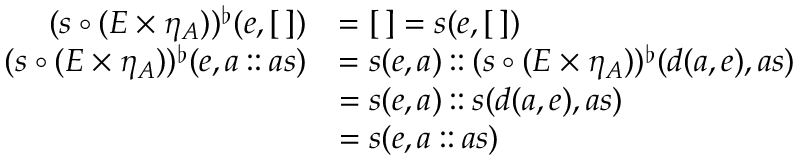Convert formula to latex. <formula><loc_0><loc_0><loc_500><loc_500>\begin{array} { r l } { ( s \circ ( E \times \eta _ { A } ) ) ^ { \flat } ( e , [ \, ] ) } & { = [ \, ] = s ( e , [ \, ] ) } \\ { ( s \circ ( E \times \eta _ { A } ) ) ^ { \flat } ( e , a \colon \colon a s ) } & { = s ( e , a ) \colon \colon ( s \circ ( E \times \eta _ { A } ) ) ^ { \flat } ( d ( a , e ) , a s ) } \\ & { = s ( e , a ) \colon \colon s ( d ( a , e ) , a s ) } \\ & { = s ( e , a \colon \colon a s ) } \end{array}</formula> 